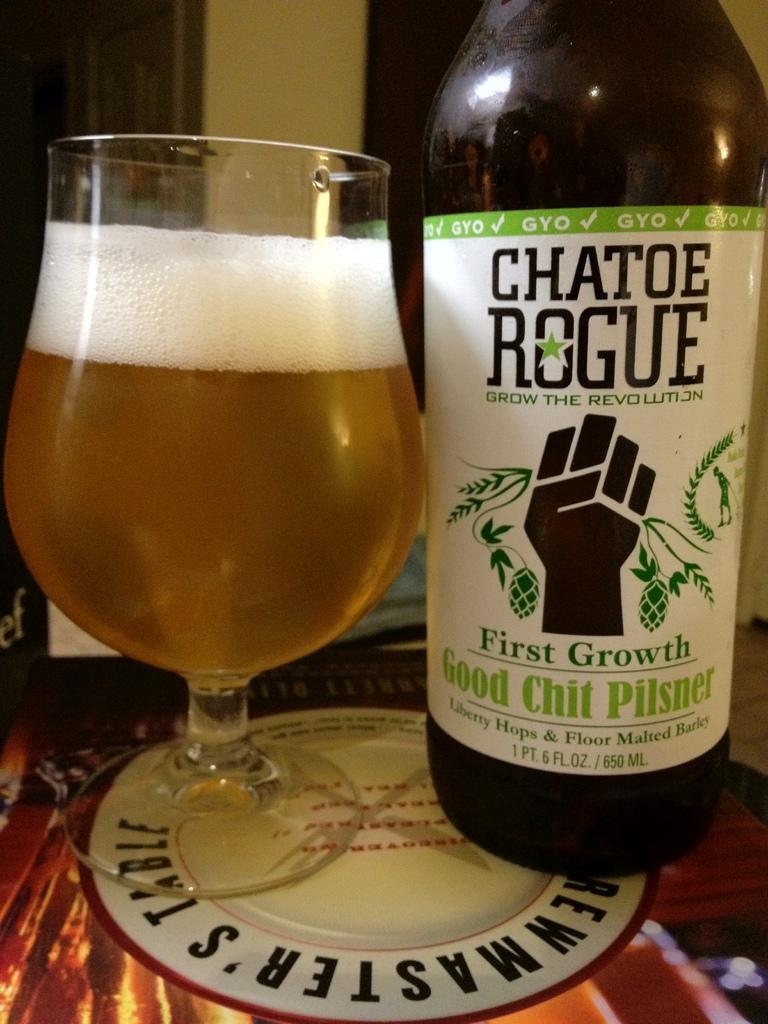<image>
Describe the image concisely. A glass of beer sitting next to a bottle of Good Chit Pilsner. 